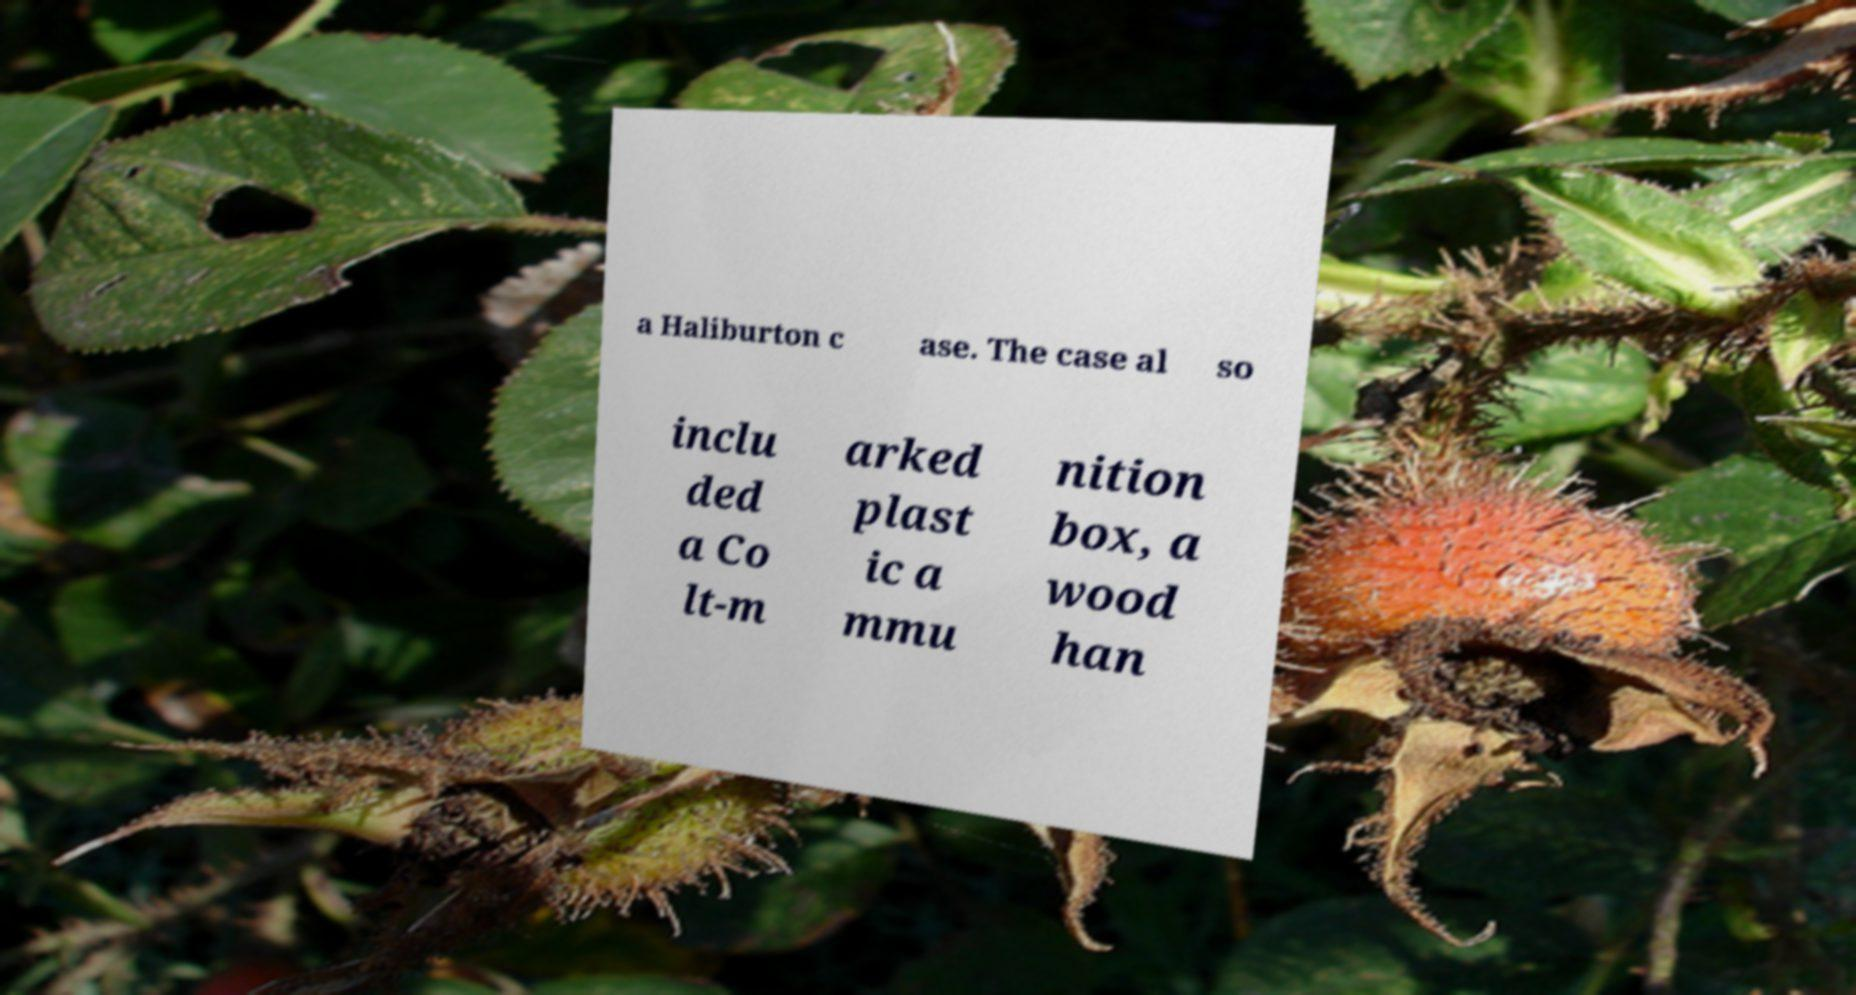Could you extract and type out the text from this image? a Haliburton c ase. The case al so inclu ded a Co lt-m arked plast ic a mmu nition box, a wood han 